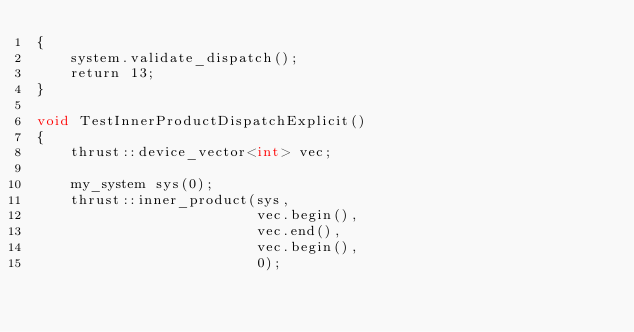Convert code to text. <code><loc_0><loc_0><loc_500><loc_500><_Cuda_>{
    system.validate_dispatch();
    return 13;
}

void TestInnerProductDispatchExplicit()
{
    thrust::device_vector<int> vec;

    my_system sys(0);
    thrust::inner_product(sys,
                          vec.begin(),
                          vec.end(),
                          vec.begin(),
                          0);
</code> 